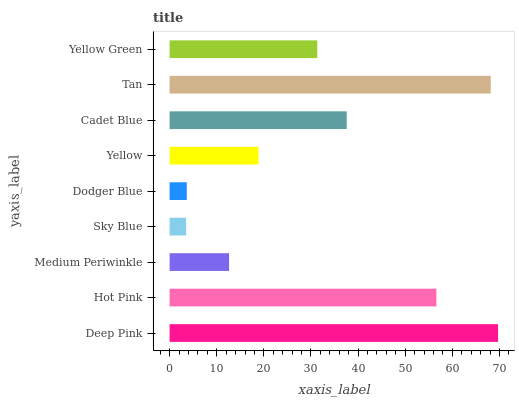Is Sky Blue the minimum?
Answer yes or no. Yes. Is Deep Pink the maximum?
Answer yes or no. Yes. Is Hot Pink the minimum?
Answer yes or no. No. Is Hot Pink the maximum?
Answer yes or no. No. Is Deep Pink greater than Hot Pink?
Answer yes or no. Yes. Is Hot Pink less than Deep Pink?
Answer yes or no. Yes. Is Hot Pink greater than Deep Pink?
Answer yes or no. No. Is Deep Pink less than Hot Pink?
Answer yes or no. No. Is Yellow Green the high median?
Answer yes or no. Yes. Is Yellow Green the low median?
Answer yes or no. Yes. Is Hot Pink the high median?
Answer yes or no. No. Is Dodger Blue the low median?
Answer yes or no. No. 